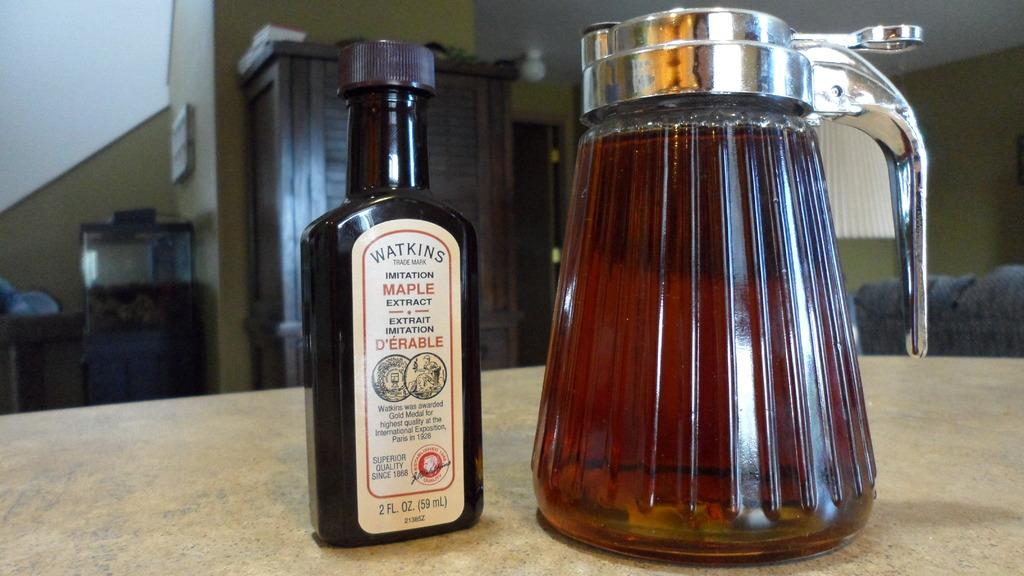<image>
Present a compact description of the photo's key features. Bottle of Warkins maple extract next toa pitcher full of syrup. 